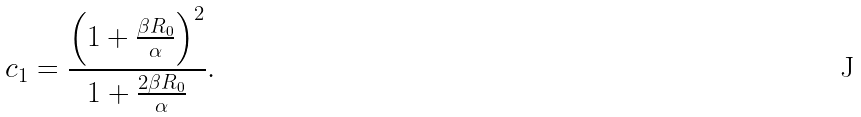Convert formula to latex. <formula><loc_0><loc_0><loc_500><loc_500>c _ { 1 } = \frac { \left ( 1 + \frac { \beta R _ { 0 } } { \alpha } \right ) ^ { 2 } } { 1 + \frac { 2 \beta R _ { 0 } } { \alpha } } .</formula> 